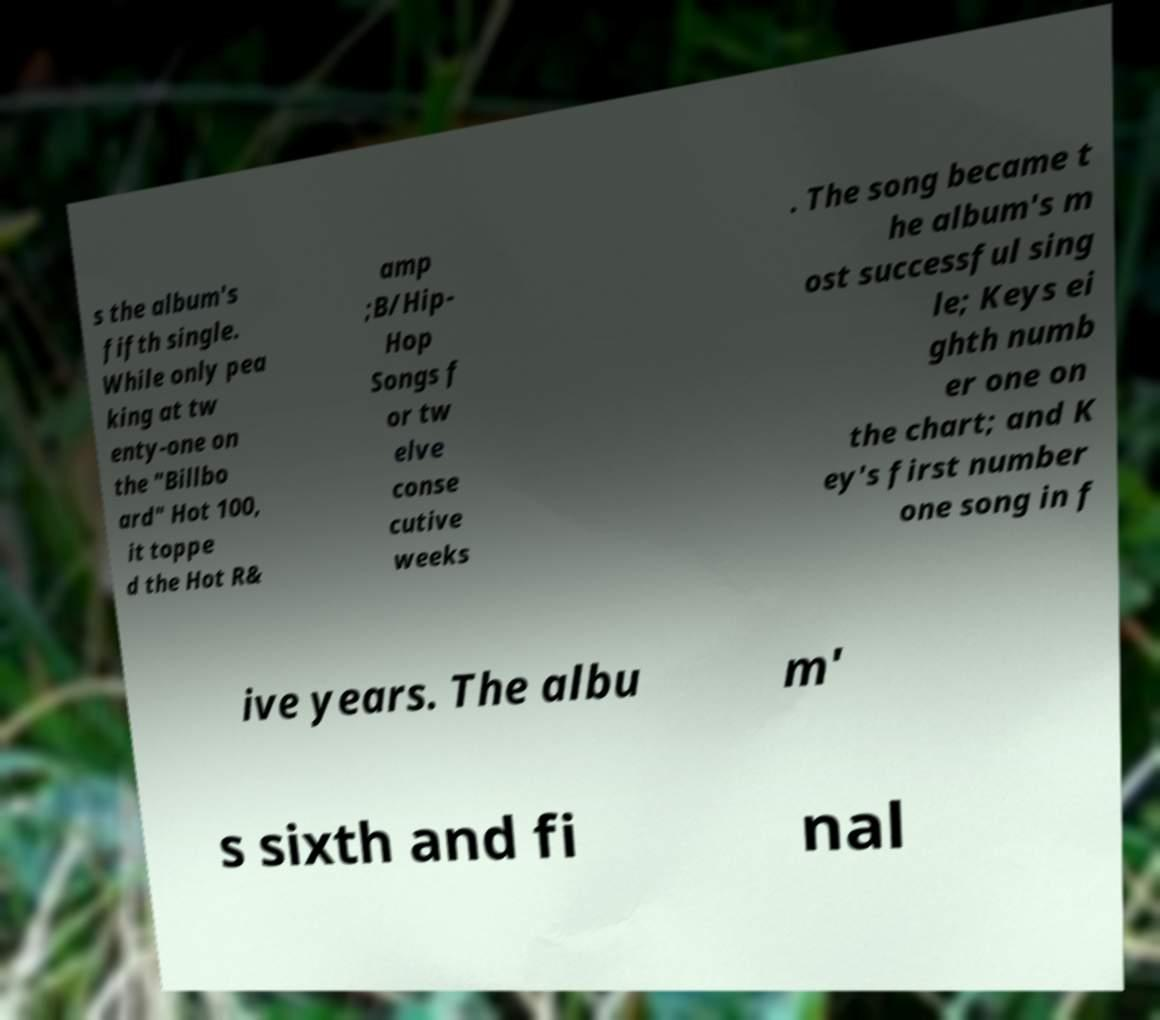Please read and relay the text visible in this image. What does it say? s the album's fifth single. While only pea king at tw enty-one on the "Billbo ard" Hot 100, it toppe d the Hot R& amp ;B/Hip- Hop Songs f or tw elve conse cutive weeks . The song became t he album's m ost successful sing le; Keys ei ghth numb er one on the chart; and K ey's first number one song in f ive years. The albu m' s sixth and fi nal 